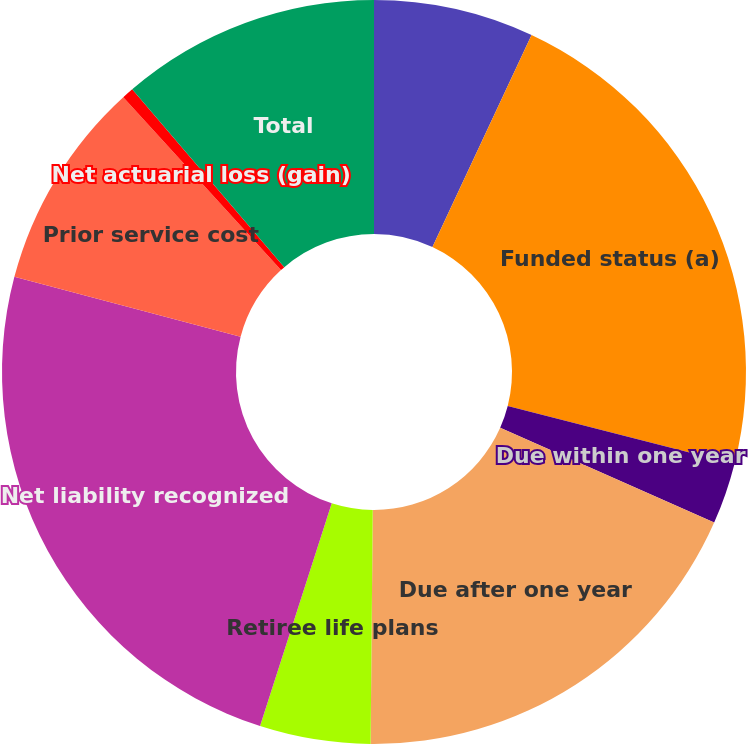Convert chart to OTSL. <chart><loc_0><loc_0><loc_500><loc_500><pie_chart><fcel>December 31 (In millions)<fcel>Funded status (a)<fcel>Due within one year<fcel>Due after one year<fcel>Retiree life plans<fcel>Net liability recognized<fcel>Prior service cost<fcel>Net actuarial loss (gain)<fcel>Total<nl><fcel>6.96%<fcel>22.01%<fcel>2.66%<fcel>18.51%<fcel>4.81%<fcel>24.16%<fcel>9.11%<fcel>0.51%<fcel>11.26%<nl></chart> 